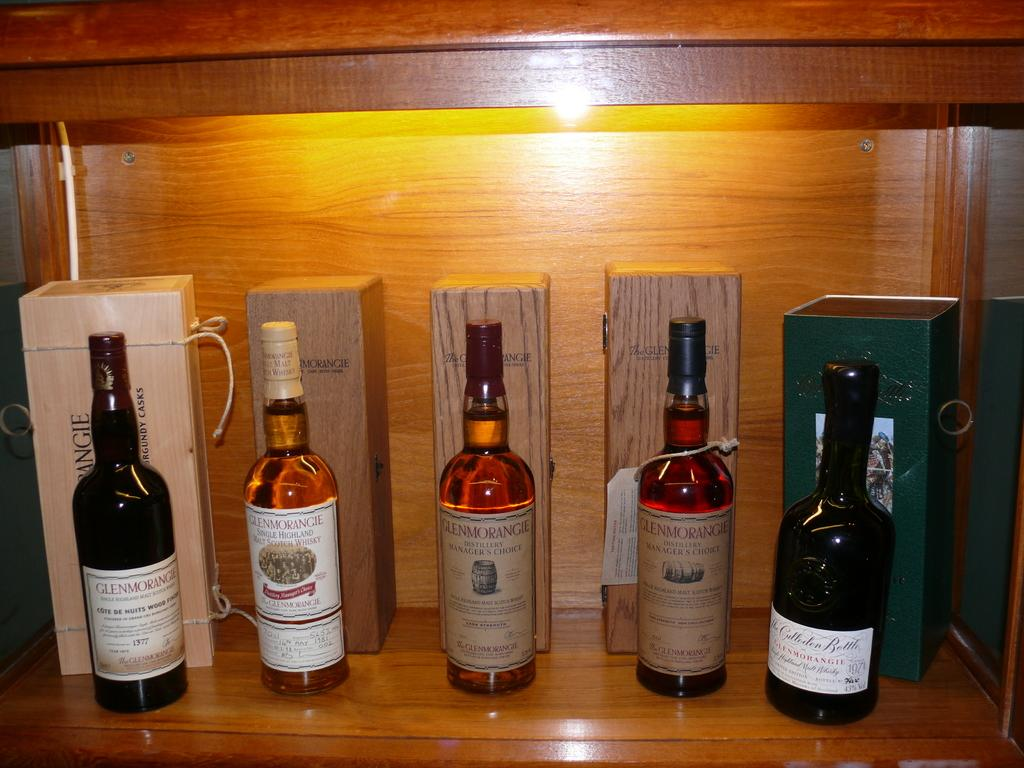What objects are visible in the image? There are bottles in the image. How are the bottles being emphasized? The bottles are highlighted in the image. What other objects can be seen behind the bottles? There are boxes behind the bottles. Are there any additional details on the bottles? Yes, there are stickers on the bottles. Can you tell me how many volleyballs are on the side of the bottles in the image? There are no volleyballs present in the image. Is there a lawyer standing next to the bottles in the image? There is no lawyer present in the image. 